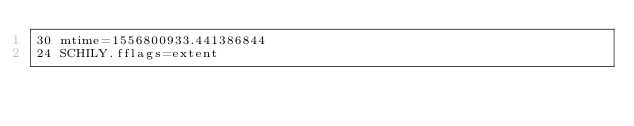Convert code to text. <code><loc_0><loc_0><loc_500><loc_500><_PHP_>30 mtime=1556800933.441386844
24 SCHILY.fflags=extent
</code> 